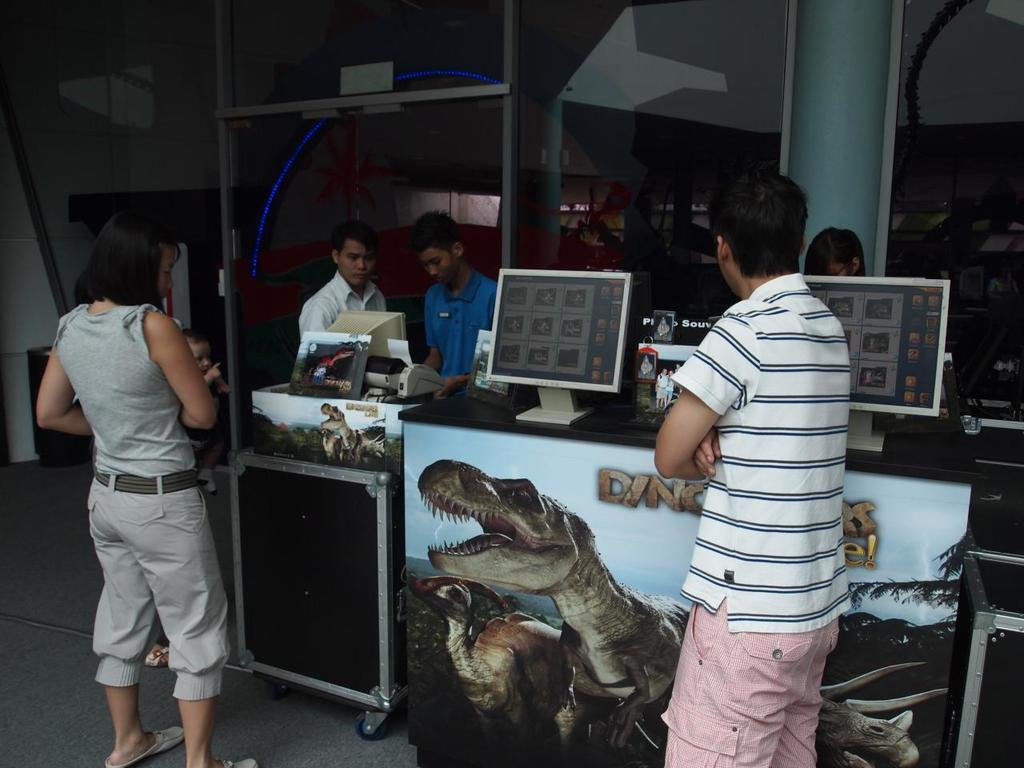What is happening in the image? There are people standing in the image. Where are the people standing? The people are standing on the floor. What can be seen on the desk in the image? There are two monitors on a desk in the image. What is visible in the background of the image? There is a wall visible in the background of the image. What type of power source is connected to the monitors in the image? There is no information about a power source connected to the monitors in the image. On which side of the desk are the monitors placed? The image does not provide information about the side of the desk where the monitors are placed. 